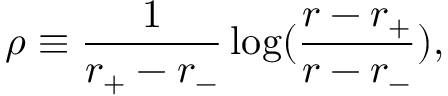Convert formula to latex. <formula><loc_0><loc_0><loc_500><loc_500>\rho \equiv \frac { 1 } { r _ { + } - r _ { - } } \log ( \frac { r - r _ { + } } { r - r _ { - } } ) ,</formula> 